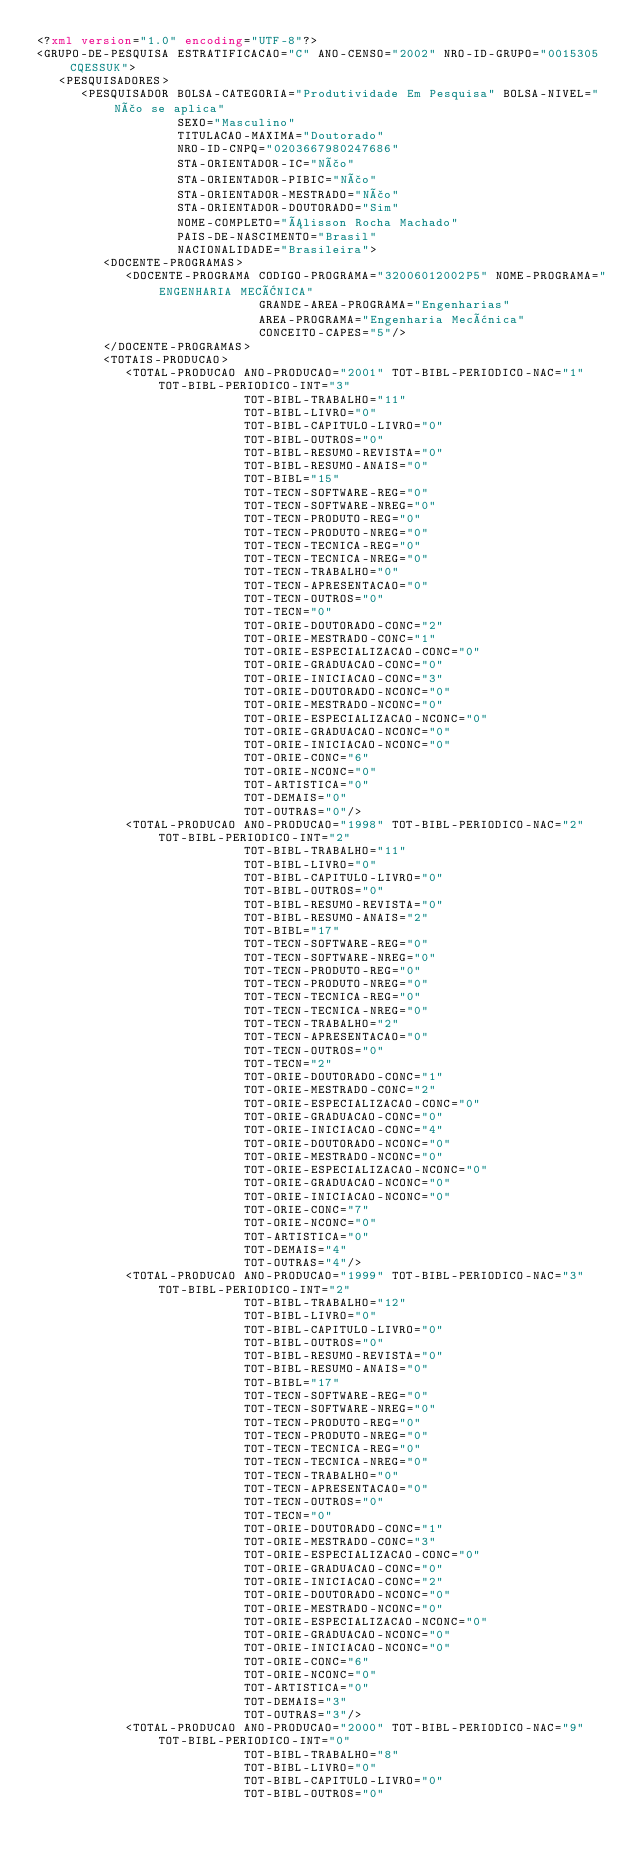Convert code to text. <code><loc_0><loc_0><loc_500><loc_500><_XML_><?xml version="1.0" encoding="UTF-8"?>
<GRUPO-DE-PESQUISA ESTRATIFICACAO="C" ANO-CENSO="2002" NRO-ID-GRUPO="0015305CQESSUK">
   <PESQUISADORES>
      <PESQUISADOR BOLSA-CATEGORIA="Produtividade Em Pesquisa" BOLSA-NIVEL="Não se aplica"
                   SEXO="Masculino"
                   TITULACAO-MAXIMA="Doutorado"
                   NRO-ID-CNPQ="0203667980247686"
                   STA-ORIENTADOR-IC="Não"
                   STA-ORIENTADOR-PIBIC="Não"
                   STA-ORIENTADOR-MESTRADO="Não"
                   STA-ORIENTADOR-DOUTORADO="Sim"
                   NOME-COMPLETO="Álisson Rocha Machado"
                   PAIS-DE-NASCIMENTO="Brasil"
                   NACIONALIDADE="Brasileira">
         <DOCENTE-PROGRAMAS>
            <DOCENTE-PROGRAMA CODIGO-PROGRAMA="32006012002P5" NOME-PROGRAMA="ENGENHARIA MECÂNICA"
                              GRANDE-AREA-PROGRAMA="Engenharias"
                              AREA-PROGRAMA="Engenharia Mecânica"
                              CONCEITO-CAPES="5"/>
         </DOCENTE-PROGRAMAS>
         <TOTAIS-PRODUCAO>
            <TOTAL-PRODUCAO ANO-PRODUCAO="2001" TOT-BIBL-PERIODICO-NAC="1" TOT-BIBL-PERIODICO-INT="3"
                            TOT-BIBL-TRABALHO="11"
                            TOT-BIBL-LIVRO="0"
                            TOT-BIBL-CAPITULO-LIVRO="0"
                            TOT-BIBL-OUTROS="0"
                            TOT-BIBL-RESUMO-REVISTA="0"
                            TOT-BIBL-RESUMO-ANAIS="0"
                            TOT-BIBL="15"
                            TOT-TECN-SOFTWARE-REG="0"
                            TOT-TECN-SOFTWARE-NREG="0"
                            TOT-TECN-PRODUTO-REG="0"
                            TOT-TECN-PRODUTO-NREG="0"
                            TOT-TECN-TECNICA-REG="0"
                            TOT-TECN-TECNICA-NREG="0"
                            TOT-TECN-TRABALHO="0"
                            TOT-TECN-APRESENTACAO="0"
                            TOT-TECN-OUTROS="0"
                            TOT-TECN="0"
                            TOT-ORIE-DOUTORADO-CONC="2"
                            TOT-ORIE-MESTRADO-CONC="1"
                            TOT-ORIE-ESPECIALIZACAO-CONC="0"
                            TOT-ORIE-GRADUACAO-CONC="0"
                            TOT-ORIE-INICIACAO-CONC="3"
                            TOT-ORIE-DOUTORADO-NCONC="0"
                            TOT-ORIE-MESTRADO-NCONC="0"
                            TOT-ORIE-ESPECIALIZACAO-NCONC="0"
                            TOT-ORIE-GRADUACAO-NCONC="0"
                            TOT-ORIE-INICIACAO-NCONC="0"
                            TOT-ORIE-CONC="6"
                            TOT-ORIE-NCONC="0"
                            TOT-ARTISTICA="0"
                            TOT-DEMAIS="0"
                            TOT-OUTRAS="0"/>
            <TOTAL-PRODUCAO ANO-PRODUCAO="1998" TOT-BIBL-PERIODICO-NAC="2" TOT-BIBL-PERIODICO-INT="2"
                            TOT-BIBL-TRABALHO="11"
                            TOT-BIBL-LIVRO="0"
                            TOT-BIBL-CAPITULO-LIVRO="0"
                            TOT-BIBL-OUTROS="0"
                            TOT-BIBL-RESUMO-REVISTA="0"
                            TOT-BIBL-RESUMO-ANAIS="2"
                            TOT-BIBL="17"
                            TOT-TECN-SOFTWARE-REG="0"
                            TOT-TECN-SOFTWARE-NREG="0"
                            TOT-TECN-PRODUTO-REG="0"
                            TOT-TECN-PRODUTO-NREG="0"
                            TOT-TECN-TECNICA-REG="0"
                            TOT-TECN-TECNICA-NREG="0"
                            TOT-TECN-TRABALHO="2"
                            TOT-TECN-APRESENTACAO="0"
                            TOT-TECN-OUTROS="0"
                            TOT-TECN="2"
                            TOT-ORIE-DOUTORADO-CONC="1"
                            TOT-ORIE-MESTRADO-CONC="2"
                            TOT-ORIE-ESPECIALIZACAO-CONC="0"
                            TOT-ORIE-GRADUACAO-CONC="0"
                            TOT-ORIE-INICIACAO-CONC="4"
                            TOT-ORIE-DOUTORADO-NCONC="0"
                            TOT-ORIE-MESTRADO-NCONC="0"
                            TOT-ORIE-ESPECIALIZACAO-NCONC="0"
                            TOT-ORIE-GRADUACAO-NCONC="0"
                            TOT-ORIE-INICIACAO-NCONC="0"
                            TOT-ORIE-CONC="7"
                            TOT-ORIE-NCONC="0"
                            TOT-ARTISTICA="0"
                            TOT-DEMAIS="4"
                            TOT-OUTRAS="4"/>
            <TOTAL-PRODUCAO ANO-PRODUCAO="1999" TOT-BIBL-PERIODICO-NAC="3" TOT-BIBL-PERIODICO-INT="2"
                            TOT-BIBL-TRABALHO="12"
                            TOT-BIBL-LIVRO="0"
                            TOT-BIBL-CAPITULO-LIVRO="0"
                            TOT-BIBL-OUTROS="0"
                            TOT-BIBL-RESUMO-REVISTA="0"
                            TOT-BIBL-RESUMO-ANAIS="0"
                            TOT-BIBL="17"
                            TOT-TECN-SOFTWARE-REG="0"
                            TOT-TECN-SOFTWARE-NREG="0"
                            TOT-TECN-PRODUTO-REG="0"
                            TOT-TECN-PRODUTO-NREG="0"
                            TOT-TECN-TECNICA-REG="0"
                            TOT-TECN-TECNICA-NREG="0"
                            TOT-TECN-TRABALHO="0"
                            TOT-TECN-APRESENTACAO="0"
                            TOT-TECN-OUTROS="0"
                            TOT-TECN="0"
                            TOT-ORIE-DOUTORADO-CONC="1"
                            TOT-ORIE-MESTRADO-CONC="3"
                            TOT-ORIE-ESPECIALIZACAO-CONC="0"
                            TOT-ORIE-GRADUACAO-CONC="0"
                            TOT-ORIE-INICIACAO-CONC="2"
                            TOT-ORIE-DOUTORADO-NCONC="0"
                            TOT-ORIE-MESTRADO-NCONC="0"
                            TOT-ORIE-ESPECIALIZACAO-NCONC="0"
                            TOT-ORIE-GRADUACAO-NCONC="0"
                            TOT-ORIE-INICIACAO-NCONC="0"
                            TOT-ORIE-CONC="6"
                            TOT-ORIE-NCONC="0"
                            TOT-ARTISTICA="0"
                            TOT-DEMAIS="3"
                            TOT-OUTRAS="3"/>
            <TOTAL-PRODUCAO ANO-PRODUCAO="2000" TOT-BIBL-PERIODICO-NAC="9" TOT-BIBL-PERIODICO-INT="0"
                            TOT-BIBL-TRABALHO="8"
                            TOT-BIBL-LIVRO="0"
                            TOT-BIBL-CAPITULO-LIVRO="0"
                            TOT-BIBL-OUTROS="0"</code> 